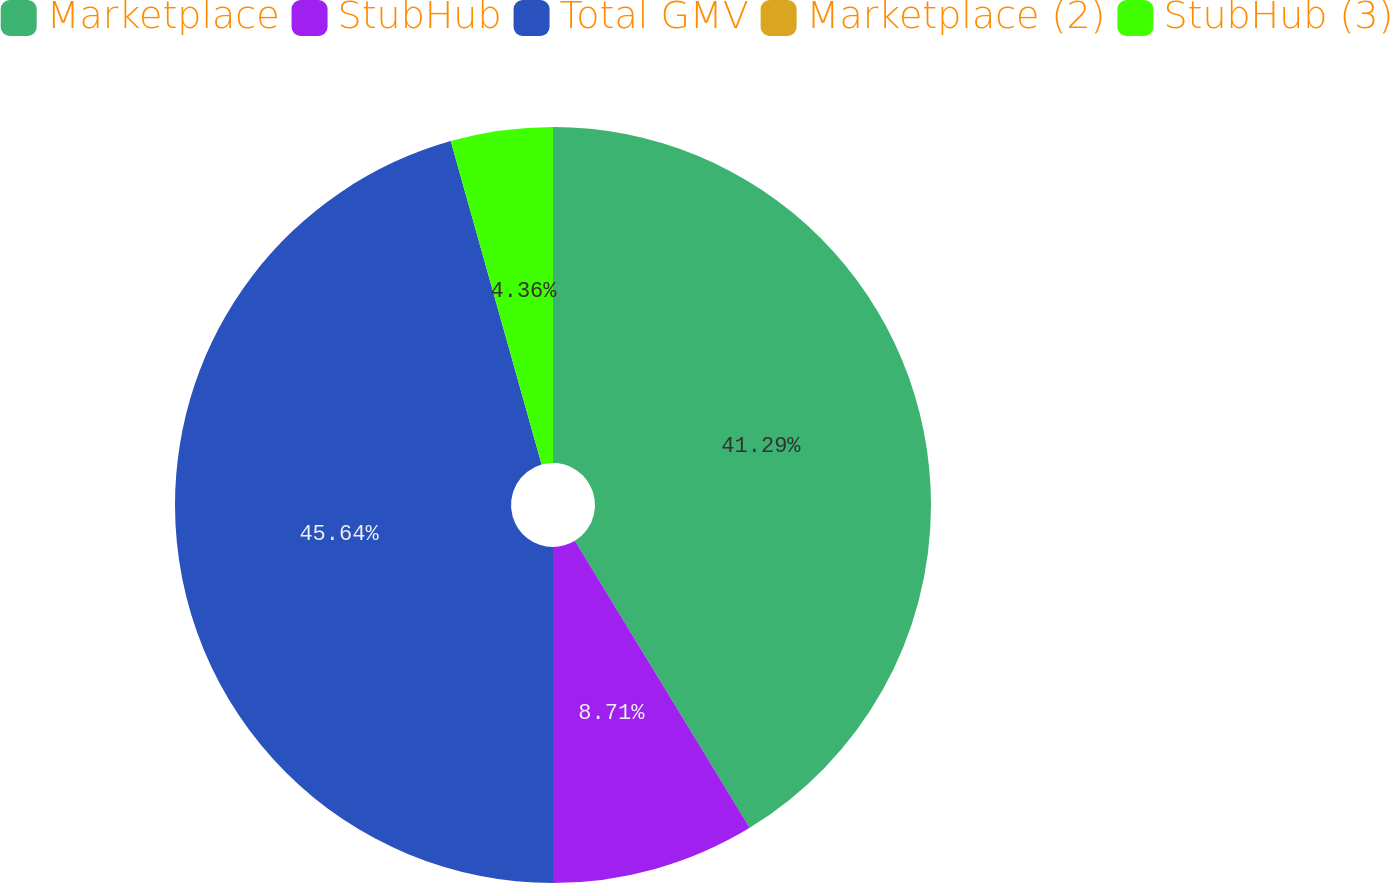Convert chart. <chart><loc_0><loc_0><loc_500><loc_500><pie_chart><fcel>Marketplace<fcel>StubHub<fcel>Total GMV<fcel>Marketplace (2)<fcel>StubHub (3)<nl><fcel>41.29%<fcel>8.71%<fcel>45.64%<fcel>0.0%<fcel>4.36%<nl></chart> 